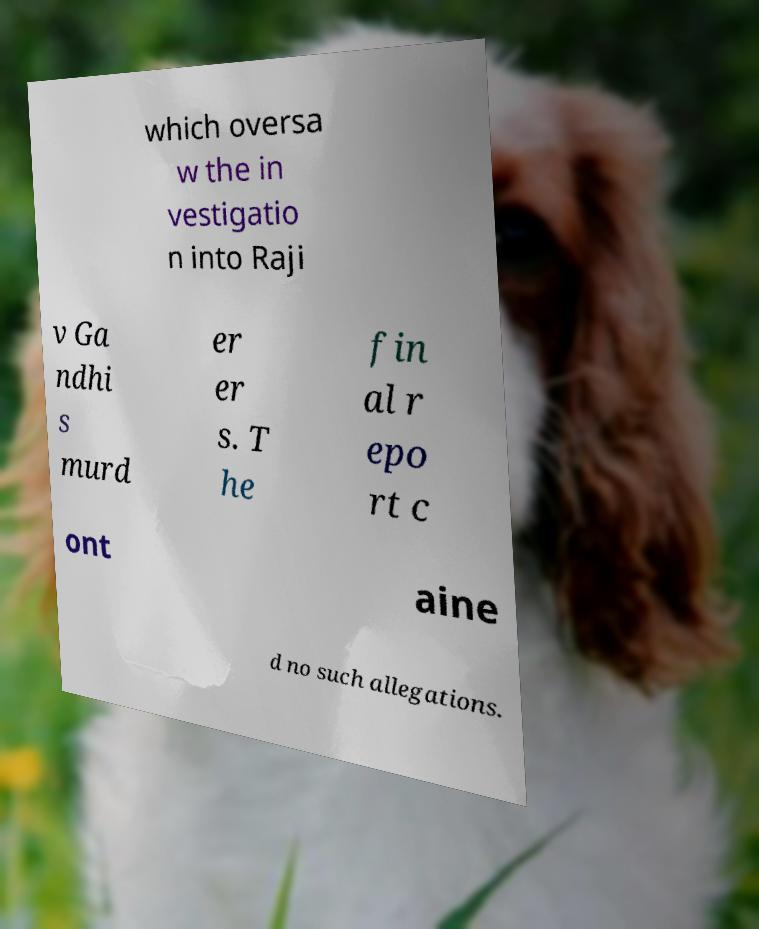There's text embedded in this image that I need extracted. Can you transcribe it verbatim? which oversa w the in vestigatio n into Raji v Ga ndhi s murd er er s. T he fin al r epo rt c ont aine d no such allegations. 